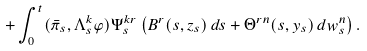Convert formula to latex. <formula><loc_0><loc_0><loc_500><loc_500>+ \int _ { 0 } ^ { t } ( \bar { \pi } _ { s } , \Lambda ^ { k } _ { s } \varphi ) \Psi ^ { k r } _ { s } \left ( B ^ { r } ( s , z _ { s } ) \, d s + \Theta ^ { r n } ( s , y _ { s } ) \, d w ^ { n } _ { s } \right ) .</formula> 